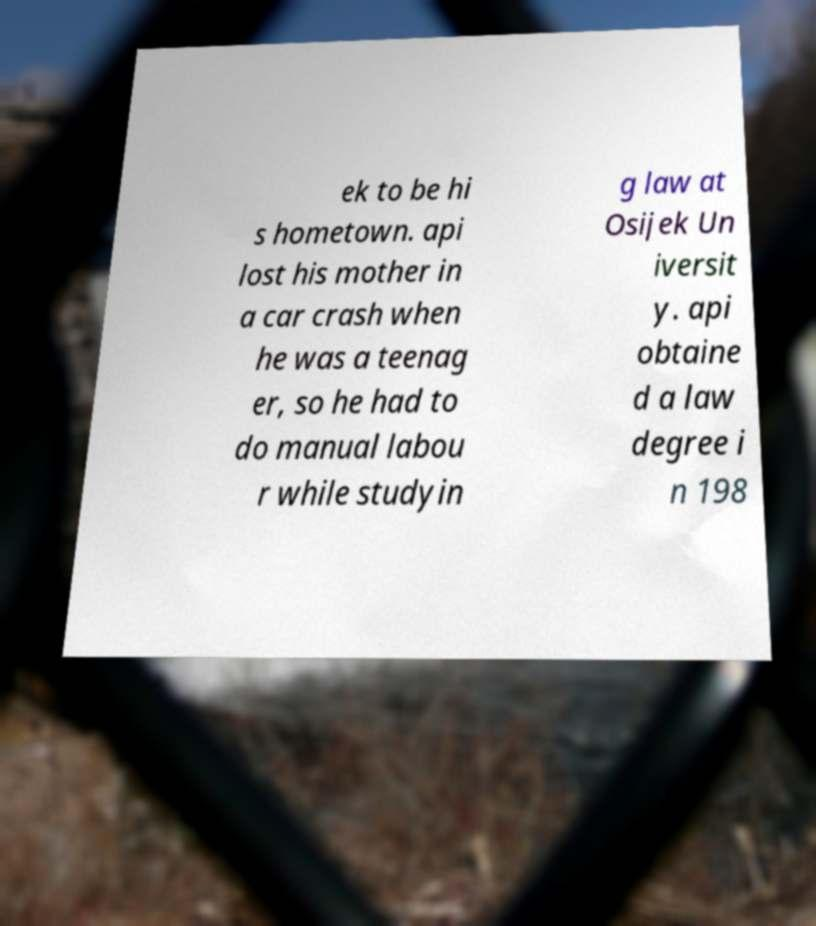Please identify and transcribe the text found in this image. ek to be hi s hometown. api lost his mother in a car crash when he was a teenag er, so he had to do manual labou r while studyin g law at Osijek Un iversit y. api obtaine d a law degree i n 198 